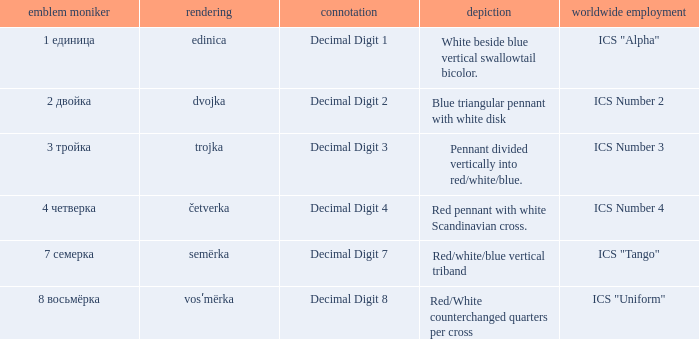What is the international use of the 1 единица flag? ICS "Alpha". 